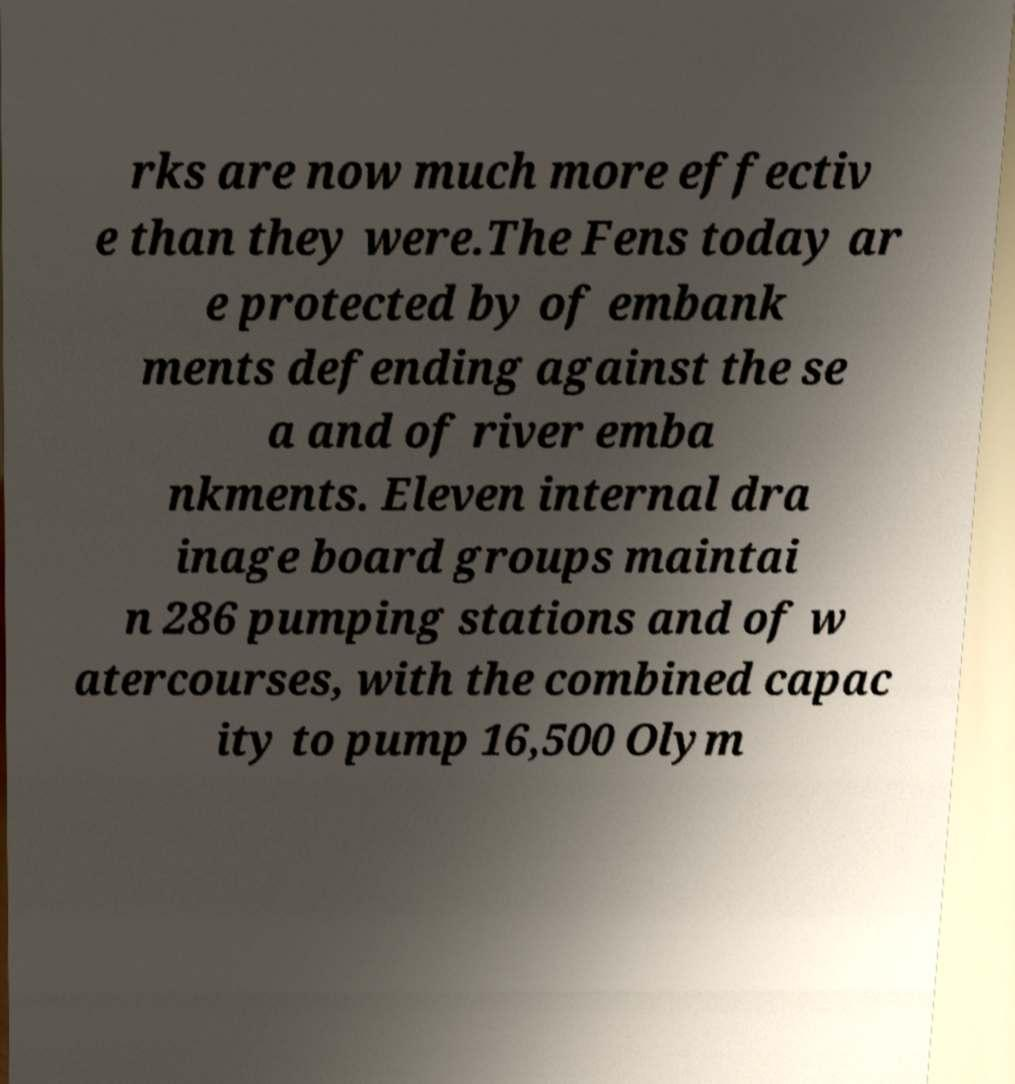There's text embedded in this image that I need extracted. Can you transcribe it verbatim? rks are now much more effectiv e than they were.The Fens today ar e protected by of embank ments defending against the se a and of river emba nkments. Eleven internal dra inage board groups maintai n 286 pumping stations and of w atercourses, with the combined capac ity to pump 16,500 Olym 